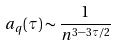Convert formula to latex. <formula><loc_0><loc_0><loc_500><loc_500>a _ { q } ( \tau ) \sim \frac { 1 } { n ^ { 3 - 3 \tau / 2 } }</formula> 